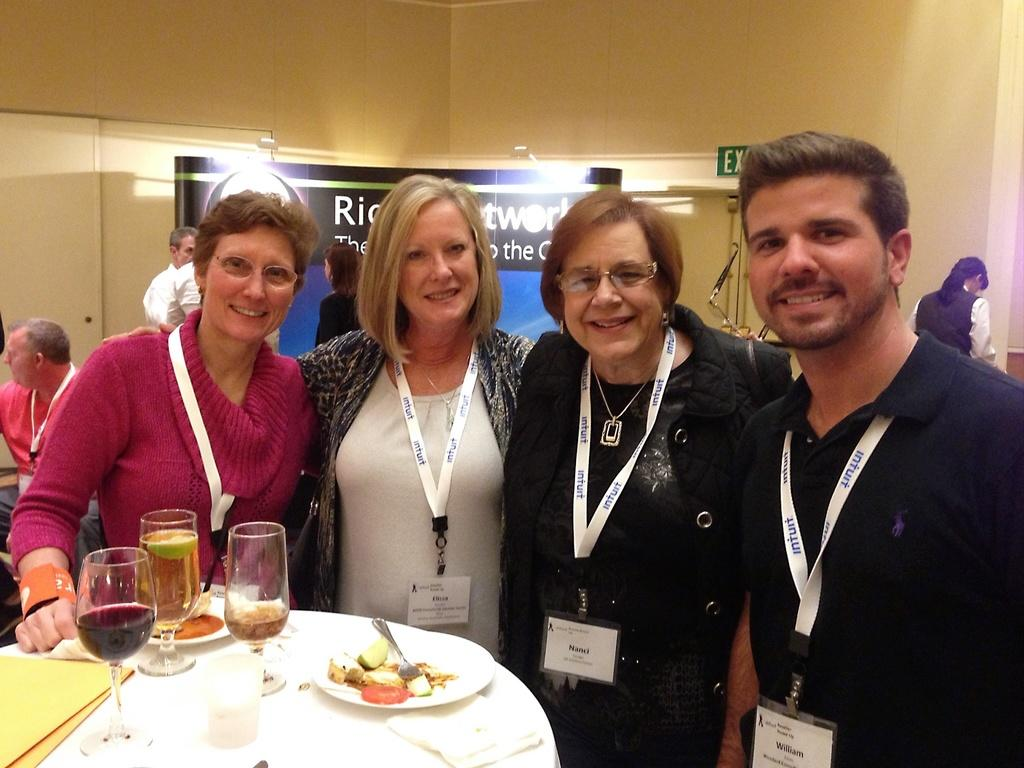How many people are in the image? There are four persons in the image. What are the persons wearing that can be seen in the image? The persons are wearing ID cards. Where are the persons standing in relation to the table? The persons are standing in front of a table. What is on the table in the image? The table contains glasses and food. What is the main feature in the middle of the image? There is a banner in the middle of the image. What type of teeth can be seen on the banner in the image? There are no teeth visible on the banner in the image. What book are the persons reading in the image? There are no books or reading material present in the image. 